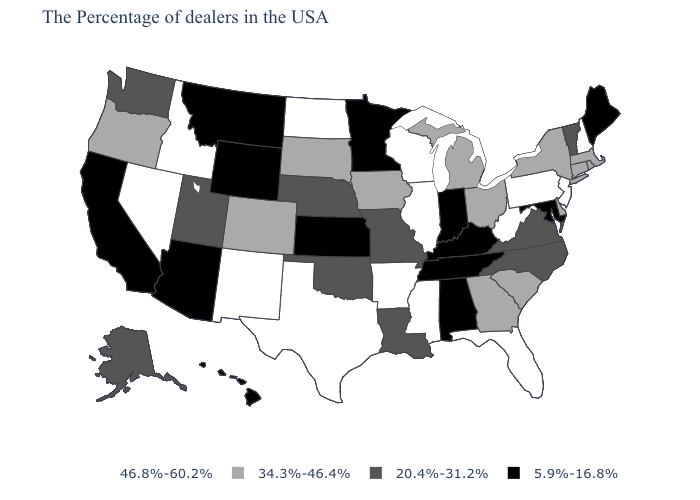What is the value of Alaska?
Write a very short answer. 20.4%-31.2%. Name the states that have a value in the range 34.3%-46.4%?
Write a very short answer. Massachusetts, Rhode Island, Connecticut, New York, Delaware, South Carolina, Ohio, Georgia, Michigan, Iowa, South Dakota, Colorado, Oregon. What is the lowest value in the USA?
Concise answer only. 5.9%-16.8%. Name the states that have a value in the range 5.9%-16.8%?
Short answer required. Maine, Maryland, Kentucky, Indiana, Alabama, Tennessee, Minnesota, Kansas, Wyoming, Montana, Arizona, California, Hawaii. Which states have the highest value in the USA?
Quick response, please. New Hampshire, New Jersey, Pennsylvania, West Virginia, Florida, Wisconsin, Illinois, Mississippi, Arkansas, Texas, North Dakota, New Mexico, Idaho, Nevada. What is the value of Missouri?
Be succinct. 20.4%-31.2%. Does Minnesota have the lowest value in the MidWest?
Write a very short answer. Yes. Is the legend a continuous bar?
Write a very short answer. No. Among the states that border Washington , does Oregon have the lowest value?
Give a very brief answer. Yes. How many symbols are there in the legend?
Short answer required. 4. What is the highest value in states that border Idaho?
Short answer required. 46.8%-60.2%. What is the highest value in states that border New York?
Be succinct. 46.8%-60.2%. Among the states that border New Hampshire , does Vermont have the lowest value?
Write a very short answer. No. Which states have the lowest value in the West?
Be succinct. Wyoming, Montana, Arizona, California, Hawaii. 